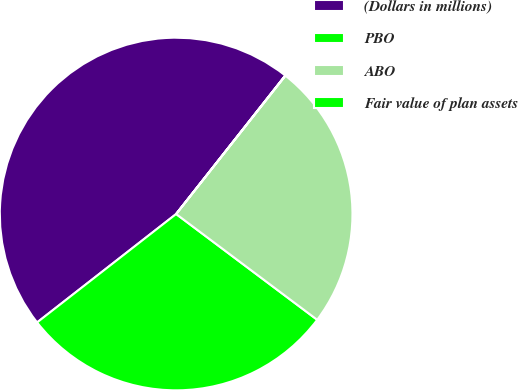<chart> <loc_0><loc_0><loc_500><loc_500><pie_chart><fcel>(Dollars in millions)<fcel>PBO<fcel>ABO<fcel>Fair value of plan assets<nl><fcel>46.16%<fcel>29.22%<fcel>24.6%<fcel>0.02%<nl></chart> 